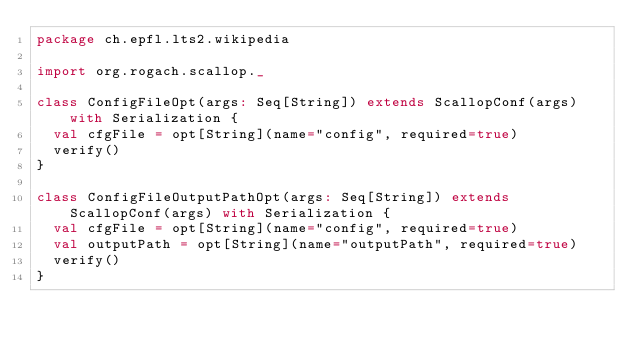Convert code to text. <code><loc_0><loc_0><loc_500><loc_500><_Scala_>package ch.epfl.lts2.wikipedia

import org.rogach.scallop._

class ConfigFileOpt(args: Seq[String]) extends ScallopConf(args) with Serialization {
  val cfgFile = opt[String](name="config", required=true)
  verify()
}

class ConfigFileOutputPathOpt(args: Seq[String]) extends ScallopConf(args) with Serialization {
  val cfgFile = opt[String](name="config", required=true)
  val outputPath = opt[String](name="outputPath", required=true)
  verify()
}</code> 